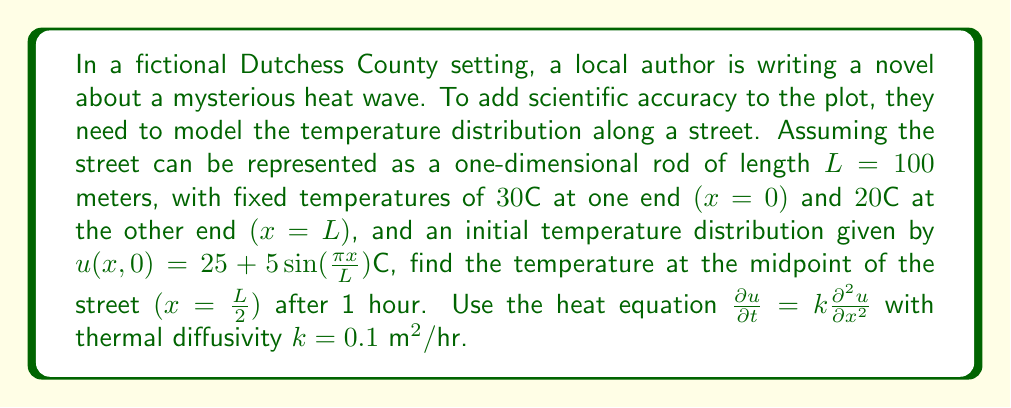Show me your answer to this math problem. To solve this problem, we'll use the separation of variables method for the heat equation with the given boundary and initial conditions.

1) The general solution of the heat equation in this case is:

   $$u(x,t) = A + Bx + \sum_{n=1}^{\infty} C_n \sin(\frac{n\pi x}{L}) e^{-k(\frac{n\pi}{L})^2t}$$

2) From the boundary conditions:
   $u(0,t) = 30°C$ and $u(L,t) = 20°C$
   We can determine $A = 30°C$ and $B = -\frac{10}{L}°C/m$

3) The initial condition is:
   $u(x,0) = 25 + 5\sin(\frac{\pi x}{L})°C$

4) Comparing this with the general solution at $t=0$:
   $$30 - \frac{10x}{L} + \sum_{n=1}^{\infty} C_n \sin(\frac{n\pi x}{L}) = 25 + 5\sin(\frac{\pi x}{L})$$

5) We can see that $C_1 = 5$ and $C_n = 0$ for $n > 1$

6) Therefore, the solution is:
   $$u(x,t) = 30 - \frac{10x}{L} + 5\sin(\frac{\pi x}{L}) e^{-k(\frac{\pi}{L})^2t}$$

7) At the midpoint $(x=\frac{L}{2})$ after 1 hour $(t=1)$:
   $$u(\frac{L}{2},1) = 30 - \frac{10(\frac{L}{2})}{L} + 5\sin(\frac{\pi (\frac{L}{2})}{L}) e^{-k(\frac{\pi}{L})^2(1)}$$
   
8) Substituting the values:
   $$u(50,1) = 30 - 5 + 5\sin(\frac{\pi}{2}) e^{-0.1(\frac{\pi}{100})^2}$$
   $$= 25 + 5 \cdot 1 \cdot e^{-0.1(\frac{\pi}{100})^2}$$
   $$\approx 25 + 5 \cdot 0.9997 = 29.9985°C$$
Answer: $29.9985°C$ 